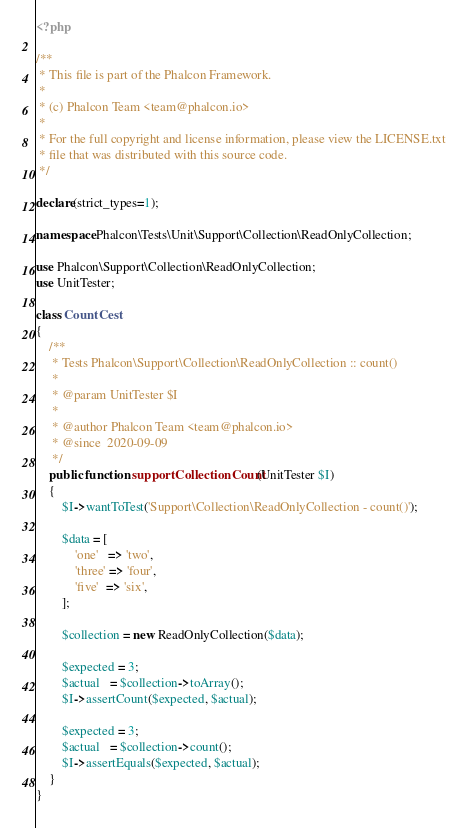<code> <loc_0><loc_0><loc_500><loc_500><_PHP_><?php

/**
 * This file is part of the Phalcon Framework.
 *
 * (c) Phalcon Team <team@phalcon.io>
 *
 * For the full copyright and license information, please view the LICENSE.txt
 * file that was distributed with this source code.
 */

declare(strict_types=1);

namespace Phalcon\Tests\Unit\Support\Collection\ReadOnlyCollection;

use Phalcon\Support\Collection\ReadOnlyCollection;
use UnitTester;

class CountCest
{
    /**
     * Tests Phalcon\Support\Collection\ReadOnlyCollection :: count()
     *
     * @param UnitTester $I
     *
     * @author Phalcon Team <team@phalcon.io>
     * @since  2020-09-09
     */
    public function supportCollectionCount(UnitTester $I)
    {
        $I->wantToTest('Support\Collection\ReadOnlyCollection - count()');

        $data = [
            'one'   => 'two',
            'three' => 'four',
            'five'  => 'six',
        ];

        $collection = new ReadOnlyCollection($data);

        $expected = 3;
        $actual   = $collection->toArray();
        $I->assertCount($expected, $actual);

        $expected = 3;
        $actual   = $collection->count();
        $I->assertEquals($expected, $actual);
    }
}
</code> 